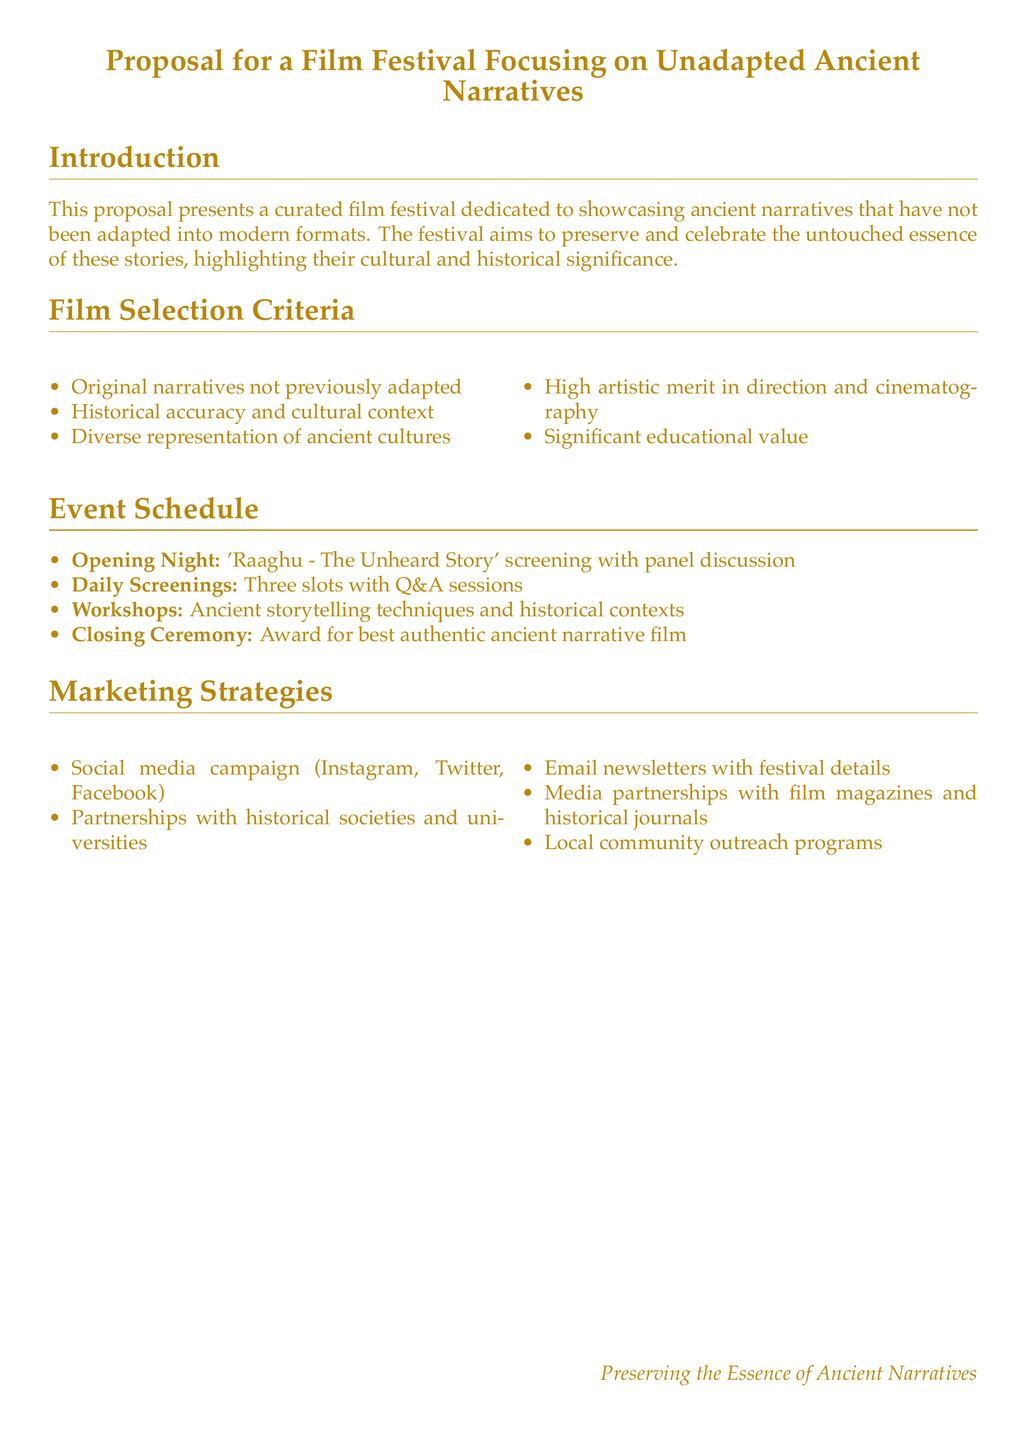What is the main focus of the film festival? The main focus of the film festival is to showcase ancient narratives that have not been adapted into modern formats.
Answer: unadapted ancient narratives What is one of the criteria for film selection? One of the criteria for film selection is that the narratives must be original and not previously adapted.
Answer: original narratives How many daily screening slots are there? The event schedule lists three daily screening slots.
Answer: three What is the title of the opening night film? The title of the opening night film is 'Raaghu - The Unheard Story.'
Answer: Raaghu - The Unheard Story What type of outreach is included in the marketing strategies? Local community outreach programs are included in the marketing strategies.
Answer: local community outreach programs What award will be presented at the closing ceremony? An award for best authentic ancient narrative film will be presented.
Answer: best authentic ancient narrative film Which social media platforms are mentioned for the campaign? The social media campaign includes Instagram, Twitter, and Facebook.
Answer: Instagram, Twitter, Facebook What type of workshops will be offered during the festival? The festival will offer workshops on ancient storytelling techniques and historical contexts.
Answer: storytelling techniques and historical contexts 